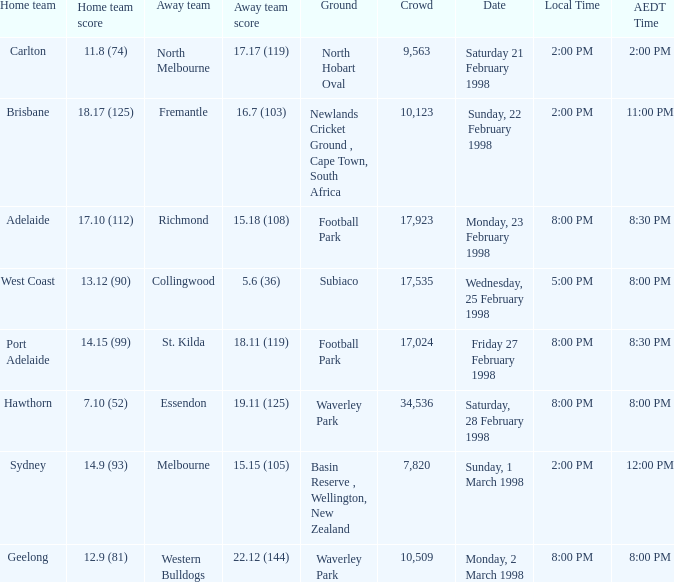Which home team is scheduled for wednesday, 25 february 1998? West Coast. 